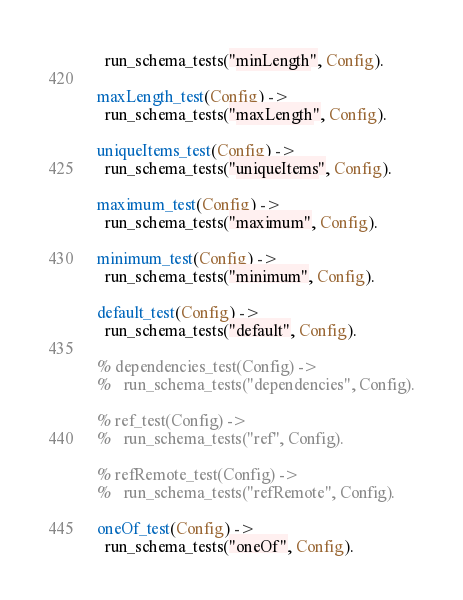<code> <loc_0><loc_0><loc_500><loc_500><_Erlang_>  run_schema_tests("minLength", Config).

maxLength_test(Config) ->
  run_schema_tests("maxLength", Config).

uniqueItems_test(Config) ->
  run_schema_tests("uniqueItems", Config).

maximum_test(Config) ->
  run_schema_tests("maximum", Config).

minimum_test(Config) ->
  run_schema_tests("minimum", Config).

default_test(Config) ->
  run_schema_tests("default", Config).

% dependencies_test(Config) ->
%   run_schema_tests("dependencies", Config).

% ref_test(Config) ->
%   run_schema_tests("ref", Config).

% refRemote_test(Config) ->
%   run_schema_tests("refRemote", Config).

oneOf_test(Config) ->
  run_schema_tests("oneOf", Config).
</code> 